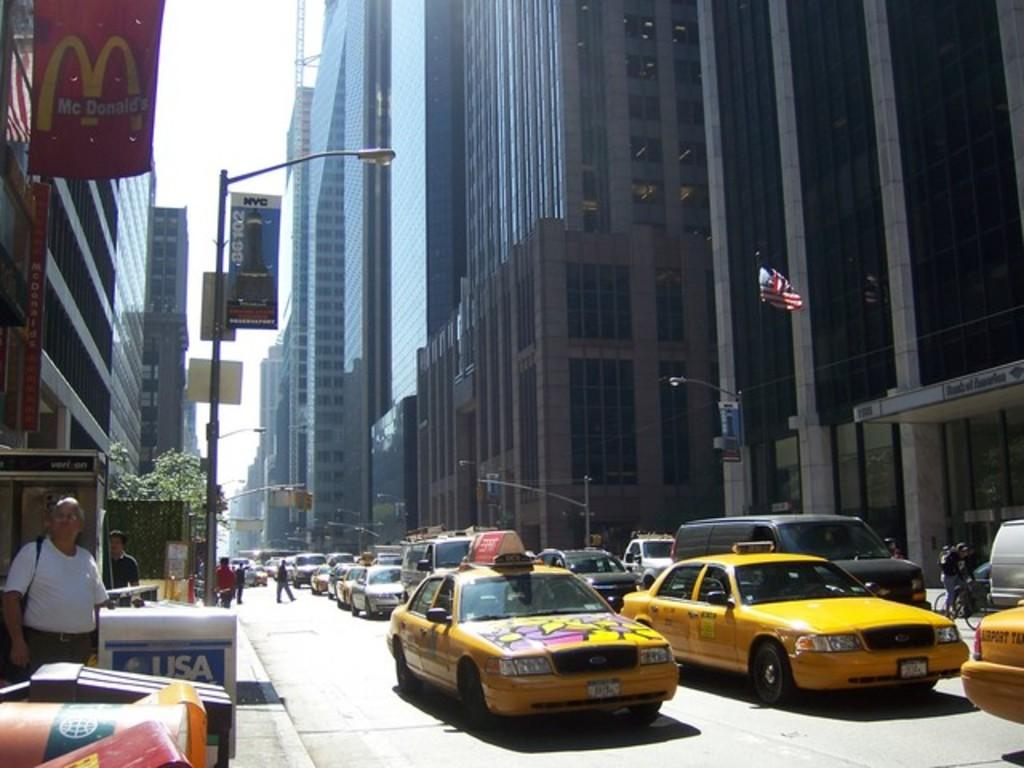<image>
Create a compact narrative representing the image presented. The white mailbox to the left says USA on it. 